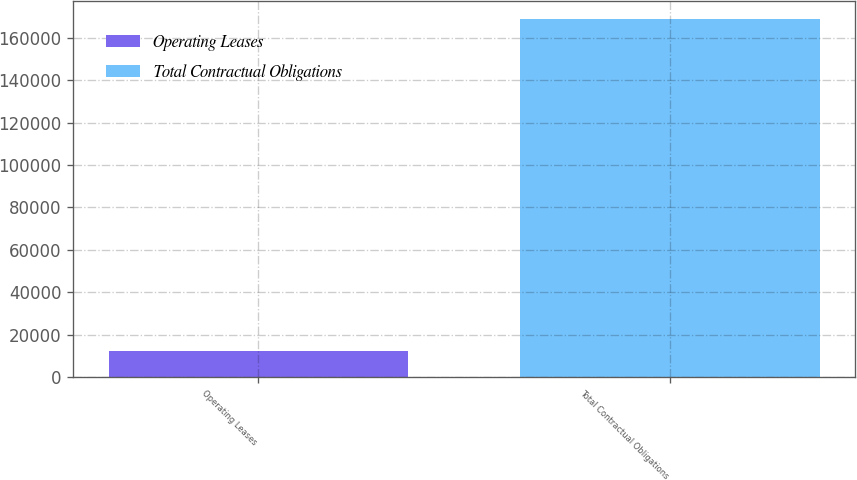<chart> <loc_0><loc_0><loc_500><loc_500><bar_chart><fcel>Operating Leases<fcel>Total Contractual Obligations<nl><fcel>12538<fcel>169009<nl></chart> 